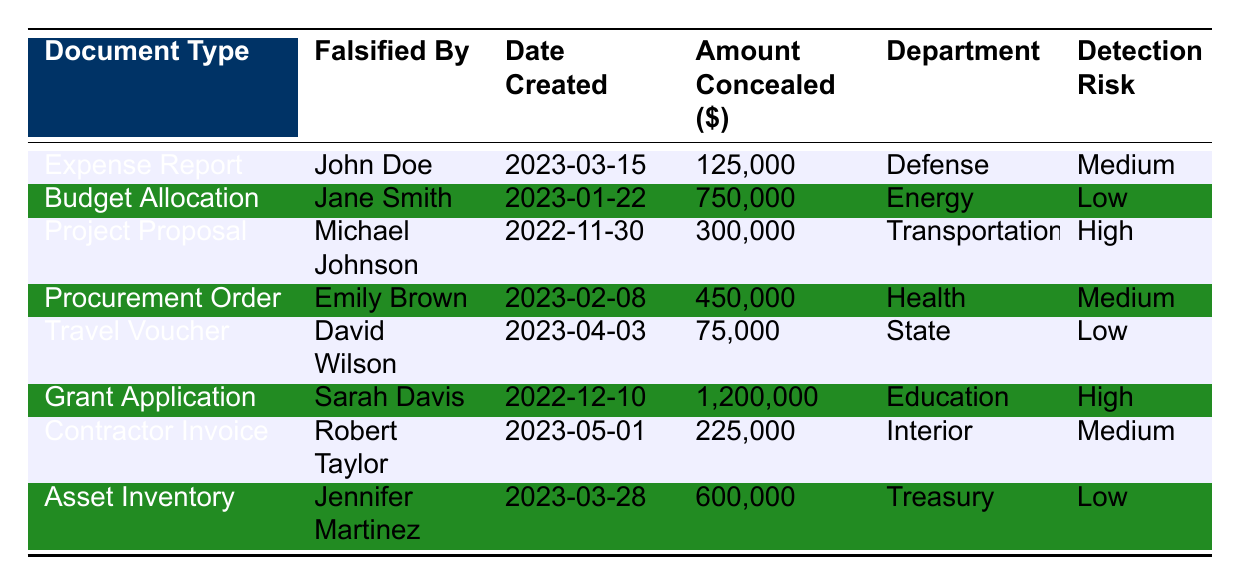What is the total amount concealed in all falsified documents? To find the total amount concealed, we need to add the individual amounts from each row. The amounts are: 125,000 + 750,000 + 300,000 + 450,000 + 75,000 + 1,200,000 + 225,000 + 600,000 = 3,725,000.
Answer: 3,725,000 Who falsified the Budget Allocation document? The table shows that the Budget Allocation document was falsified by Jane Smith.
Answer: Jane Smith What is the detection risk level of the Travel Voucher? According to the table, the detection risk level for the Travel Voucher is low.
Answer: Low Which document type has the highest amount concealed? By comparing the amounts concealed in the rows, the Grant Application shows the highest amount at 1,200,000.
Answer: Grant Application Is there any document that was falsified by more than one person? The table specifies that each document was falsified by a unique individual; hence, no document was falsified by more than one person.
Answer: No What is the average amount concealed for documents classified as 'Medium' detection risk? The documents with 'Medium' detection risk are: Expense Report (125,000), Procurement Order (450,000), and Contractor Invoice (225,000). The total amount is 125,000 + 450,000 + 225,000 = 800,000. There are 3 such documents, so the average is 800,000 / 3 = 266,667.
Answer: 266,667 Which department had the lowest detection risk for falsified documents? The table lists departments with low detection risk as Energy, State, and Treasury. Since there are three with equal risk, we can highlight that all are at low risk.
Answer: Energy, State, Treasury Which individual is associated with the highest single concealed amount? From the table, Sarah Davis is associated with the Grant Application, which has the highest single concealed amount of 1,200,000.
Answer: Sarah Davis What is the difference between the highest and lowest amounts concealed? The highest amount concealed is 1,200,000 (from the Grant Application), and the lowest is 75,000 (from the Travel Voucher). Therefore, the difference is 1,200,000 - 75,000 = 1,125,000.
Answer: 1,125,000 How many distinct document types are recorded in the inventory? The table shows 8 distinct document types: Expense Report, Budget Allocation, Project Proposal, Procurement Order, Travel Voucher, Grant Application, Contractor Invoice, and Asset Inventory.
Answer: 8 